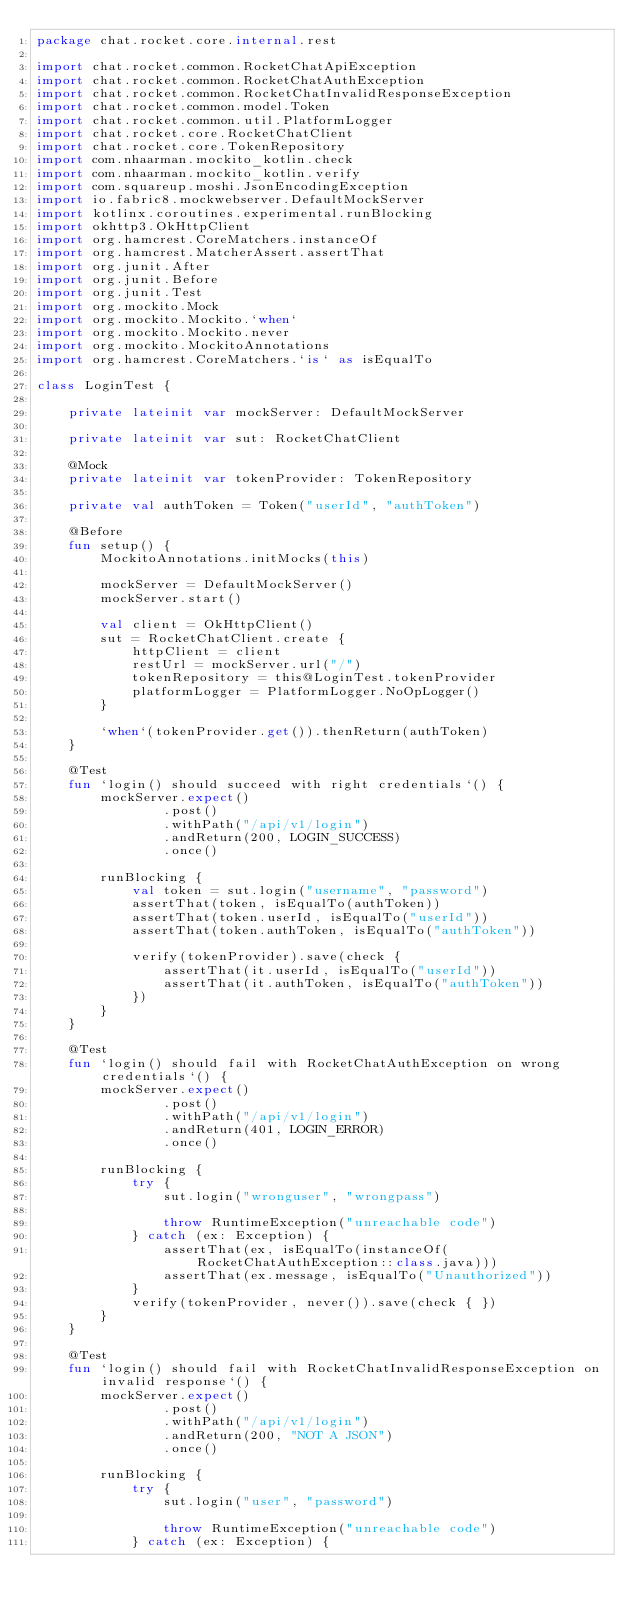Convert code to text. <code><loc_0><loc_0><loc_500><loc_500><_Kotlin_>package chat.rocket.core.internal.rest

import chat.rocket.common.RocketChatApiException
import chat.rocket.common.RocketChatAuthException
import chat.rocket.common.RocketChatInvalidResponseException
import chat.rocket.common.model.Token
import chat.rocket.common.util.PlatformLogger
import chat.rocket.core.RocketChatClient
import chat.rocket.core.TokenRepository
import com.nhaarman.mockito_kotlin.check
import com.nhaarman.mockito_kotlin.verify
import com.squareup.moshi.JsonEncodingException
import io.fabric8.mockwebserver.DefaultMockServer
import kotlinx.coroutines.experimental.runBlocking
import okhttp3.OkHttpClient
import org.hamcrest.CoreMatchers.instanceOf
import org.hamcrest.MatcherAssert.assertThat
import org.junit.After
import org.junit.Before
import org.junit.Test
import org.mockito.Mock
import org.mockito.Mockito.`when`
import org.mockito.Mockito.never
import org.mockito.MockitoAnnotations
import org.hamcrest.CoreMatchers.`is` as isEqualTo

class LoginTest {

    private lateinit var mockServer: DefaultMockServer

    private lateinit var sut: RocketChatClient

    @Mock
    private lateinit var tokenProvider: TokenRepository

    private val authToken = Token("userId", "authToken")

    @Before
    fun setup() {
        MockitoAnnotations.initMocks(this)

        mockServer = DefaultMockServer()
        mockServer.start()

        val client = OkHttpClient()
        sut = RocketChatClient.create {
            httpClient = client
            restUrl = mockServer.url("/")
            tokenRepository = this@LoginTest.tokenProvider
            platformLogger = PlatformLogger.NoOpLogger()
        }

        `when`(tokenProvider.get()).thenReturn(authToken)
    }

    @Test
    fun `login() should succeed with right credentials`() {
        mockServer.expect()
                .post()
                .withPath("/api/v1/login")
                .andReturn(200, LOGIN_SUCCESS)
                .once()

        runBlocking {
            val token = sut.login("username", "password")
            assertThat(token, isEqualTo(authToken))
            assertThat(token.userId, isEqualTo("userId"))
            assertThat(token.authToken, isEqualTo("authToken"))

            verify(tokenProvider).save(check {
                assertThat(it.userId, isEqualTo("userId"))
                assertThat(it.authToken, isEqualTo("authToken"))
            })
        }
    }

    @Test
    fun `login() should fail with RocketChatAuthException on wrong credentials`() {
        mockServer.expect()
                .post()
                .withPath("/api/v1/login")
                .andReturn(401, LOGIN_ERROR)
                .once()

        runBlocking {
            try {
                sut.login("wronguser", "wrongpass")

                throw RuntimeException("unreachable code")
            } catch (ex: Exception) {
                assertThat(ex, isEqualTo(instanceOf(RocketChatAuthException::class.java)))
                assertThat(ex.message, isEqualTo("Unauthorized"))
            }
            verify(tokenProvider, never()).save(check { })
        }
    }

    @Test
    fun `login() should fail with RocketChatInvalidResponseException on invalid response`() {
        mockServer.expect()
                .post()
                .withPath("/api/v1/login")
                .andReturn(200, "NOT A JSON")
                .once()

        runBlocking {
            try {
                sut.login("user", "password")

                throw RuntimeException("unreachable code")
            } catch (ex: Exception) {</code> 